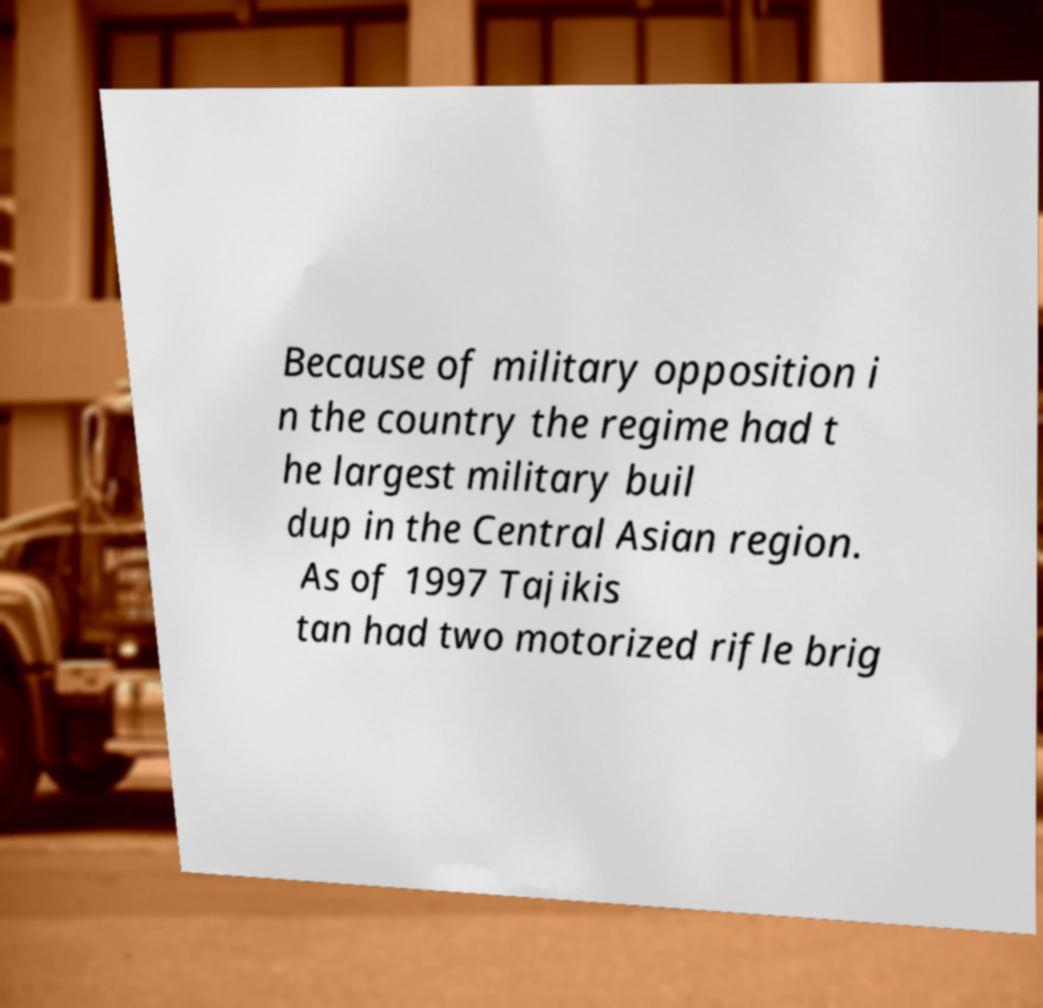What messages or text are displayed in this image? I need them in a readable, typed format. Because of military opposition i n the country the regime had t he largest military buil dup in the Central Asian region. As of 1997 Tajikis tan had two motorized rifle brig 